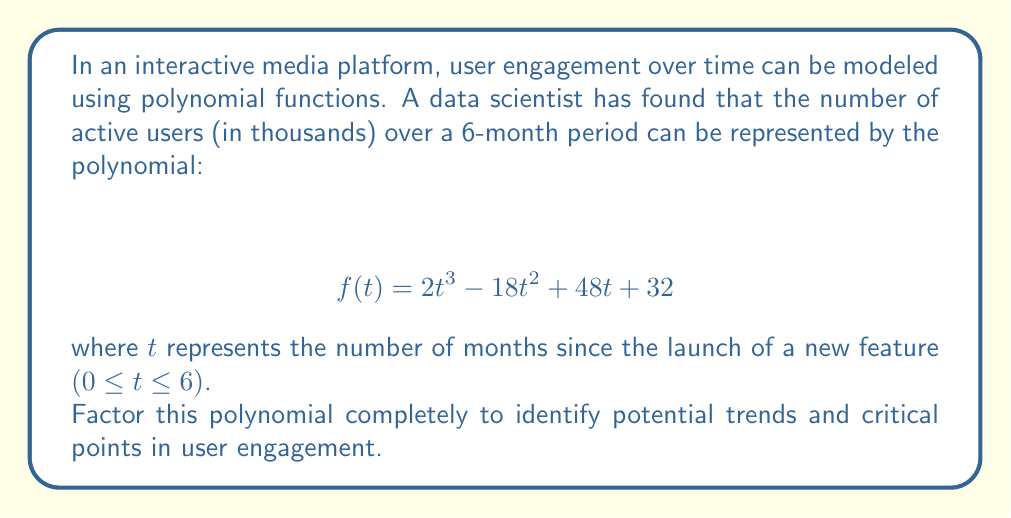Provide a solution to this math problem. To factor this polynomial, we'll follow these steps:

1) First, check if there's a common factor:
   $2t^3 - 18t^2 + 48t + 32$
   There's no common factor for all terms.

2) This is a cubic polynomial. Let's try to find a root by testing some factors of the constant term (32):
   Possible factors: ±1, ±2, ±4, ±8, ±16, ±32
   
   Testing $f(-2)$:
   $2(-2)^3 - 18(-2)^2 + 48(-2) + 32$
   $= -16 - 72 - 96 + 32 = -152$
   
   Testing $f(2)$:
   $2(2)^3 - 18(2)^2 + 48(2) + 32$
   $= 16 - 72 + 96 + 32 = 72$
   
   Testing $f(-1)$:
   $2(-1)^3 - 18(-1)^2 + 48(-1) + 32$
   $= -2 - 18 - 48 + 32 = -36$
   
   Testing $f(1)$:
   $2(1)^3 - 18(1)^2 + 48(1) + 32$
   $= 2 - 18 + 48 + 32 = 64$
   
   We find that $f(2) = 0$, so $(t-2)$ is a factor.

3) Divide the polynomial by $(t-2)$ using polynomial long division:

   $2t^3 - 18t^2 + 48t + 32 = (t-2)(2t^2 + 4t + 16)$

4) Now we need to factor the quadratic $2t^2 + 4t + 16$:
   
   a) First, factor out the GCD: $2(t^2 + 2t + 8)$
   
   b) For $t^2 + 2t + 8$, check if it's a perfect square trinomial:
      $(t + 1)^2 = t^2 + 2t + 1$, which doesn't match.
   
   c) Use the quadratic formula: $\frac{-b \pm \sqrt{b^2 - 4ac}}{2a}$
      $\frac{-2 \pm \sqrt{4 - 4(1)(8)}}{2(1)} = \frac{-2 \pm \sqrt{-28}}{2}$
   
   This quadratic has no real roots, so it can't be factored further.

5) Therefore, the complete factorization is:

   $f(t) = 2(t-2)(t^2 + 2t + 8)$

This factorization reveals that there's a critical point at $t=2$ months, which could represent a significant change in user engagement two months after the new feature launch.
Answer: $f(t) = 2(t-2)(t^2 + 2t + 8)$ 